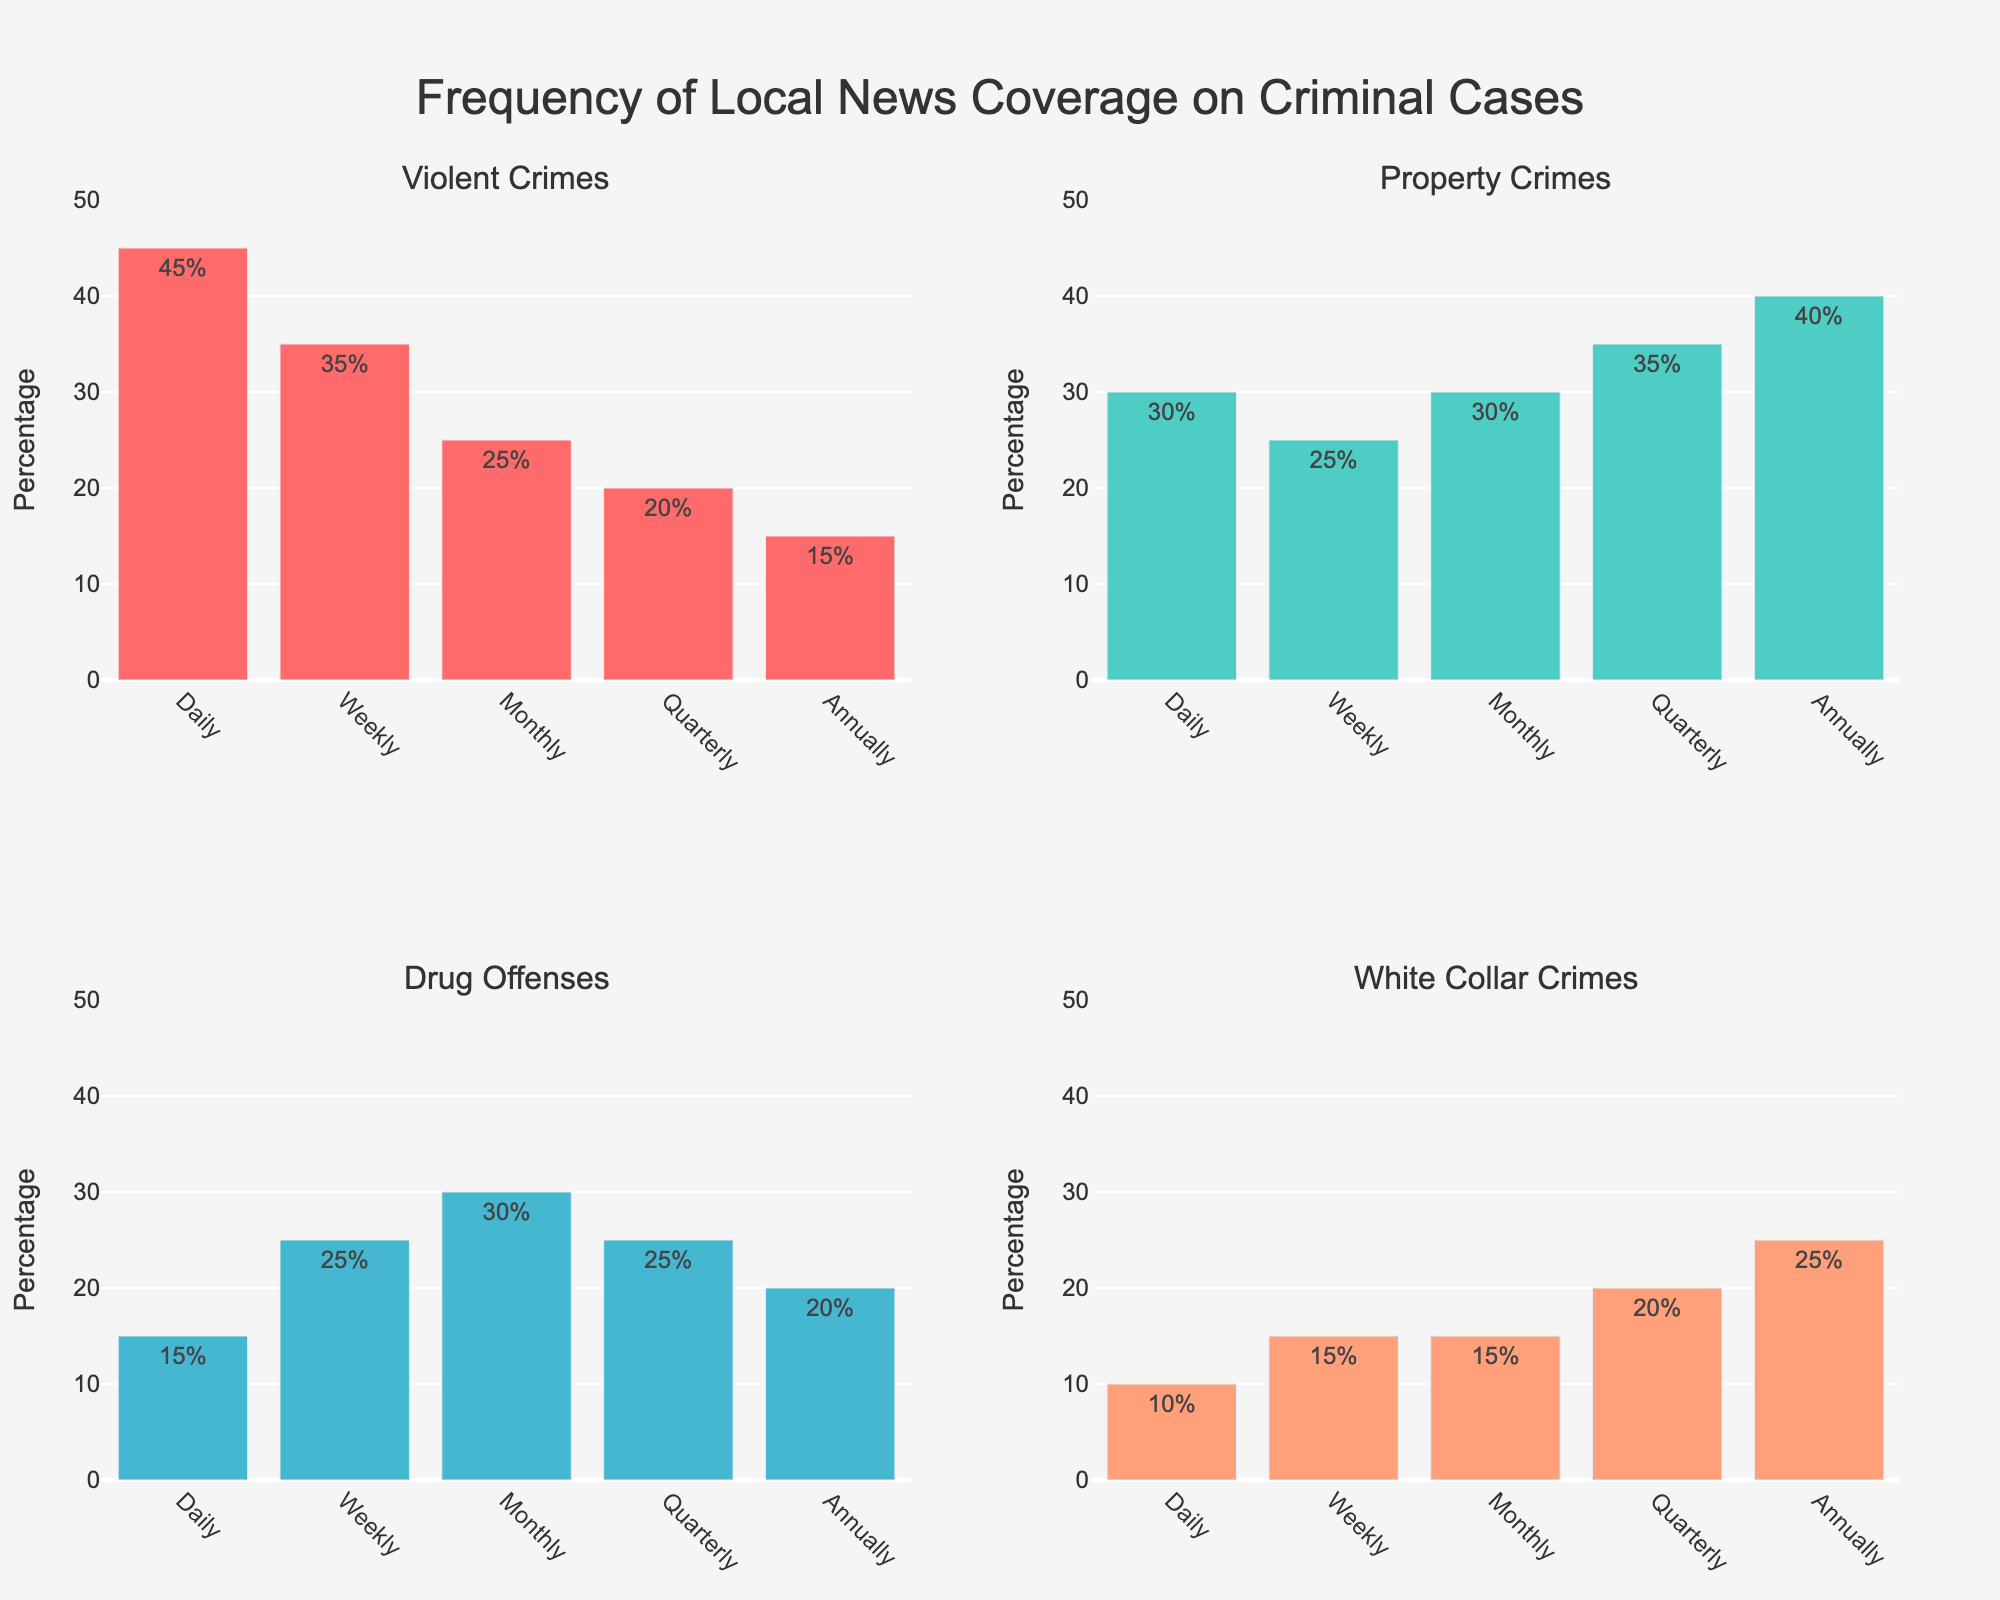What is the title of the figure? The title of the figure is usually located at the top center. It reads: 'Frequency of Local News Coverage on Criminal Cases'.
Answer: Frequency of Local News Coverage on Criminal Cases Which crime category has the highest percentage for 'Daily' coverage? Look at the 'Daily' bar on each subplot. The longest bar corresponds to 'Violent Crimes'.
Answer: Violent Crimes What is the percentage of news coverage on 'Drug Offenses' that is reported 'Weekly'? Find the 'Weekly' bar in the 'Drug Offenses' subplot and read the percentage label attached to it, which is 25%.
Answer: 25% Which crime category has the lowest percentage for 'Annually' coverage? Check the 'Annually' bars across all four subplots. The shortest bar corresponds to 'Violent Crimes'.
Answer: Violent Crimes What is the sum of the percentages for 'Property Crimes' reported 'Daily' and 'Monthly'? Find the percentages of 'Property Crimes' for 'Daily' and 'Monthly': 30% and 30%. Add them together: 30% + 30% = 60%.
Answer: 60% For 'Quarterly' coverage, which crime category has a higher percentage, 'Property Crimes' or 'Drug Offenses'? Compare the 'Quarterly' bars in 'Property Crimes' and 'Drug Offenses' subplots. 'Property Crimes' has 35%, while 'Drug Offenses' has 25%.
Answer: Property Crimes What is the average percentage of 'Violent Crimes' covered 'Weekly' and 'Monthly'? Find the percentages for 'Violent Crimes' on 'Weekly' and 'Monthly': 35% and 25%. Calculate the average: (35% + 25%) / 2 = 30%.
Answer: 30% Which crime category's news coverage shows a steady increase from 'Daily' to 'Annually'? Examine the bars from 'Daily' to 'Annually' for all categories. 'White Collar Crimes' shows a steady increase from 10% to 25%.
Answer: White Collar Crimes Comparing 'Daily' and 'Weekly' coverage, which crime category shows a greater percentage drop in news coverage? Find the difference between 'Daily' and 'Weekly' percentages for each category. The differences are: 'Violent Crimes' (45%-35%=10%), 'Property Crimes' (30%-25%=5%), 'Drug Offenses' (15%-25%=-10%), 'White Collar Crimes' (10%-15%=-5%). The greatest drop is in 'Drug Offenses'.
Answer: Drug Offenses 